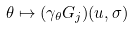Convert formula to latex. <formula><loc_0><loc_0><loc_500><loc_500>\theta \mapsto ( \gamma _ { \theta } G _ { j } ) ( u , \sigma )</formula> 